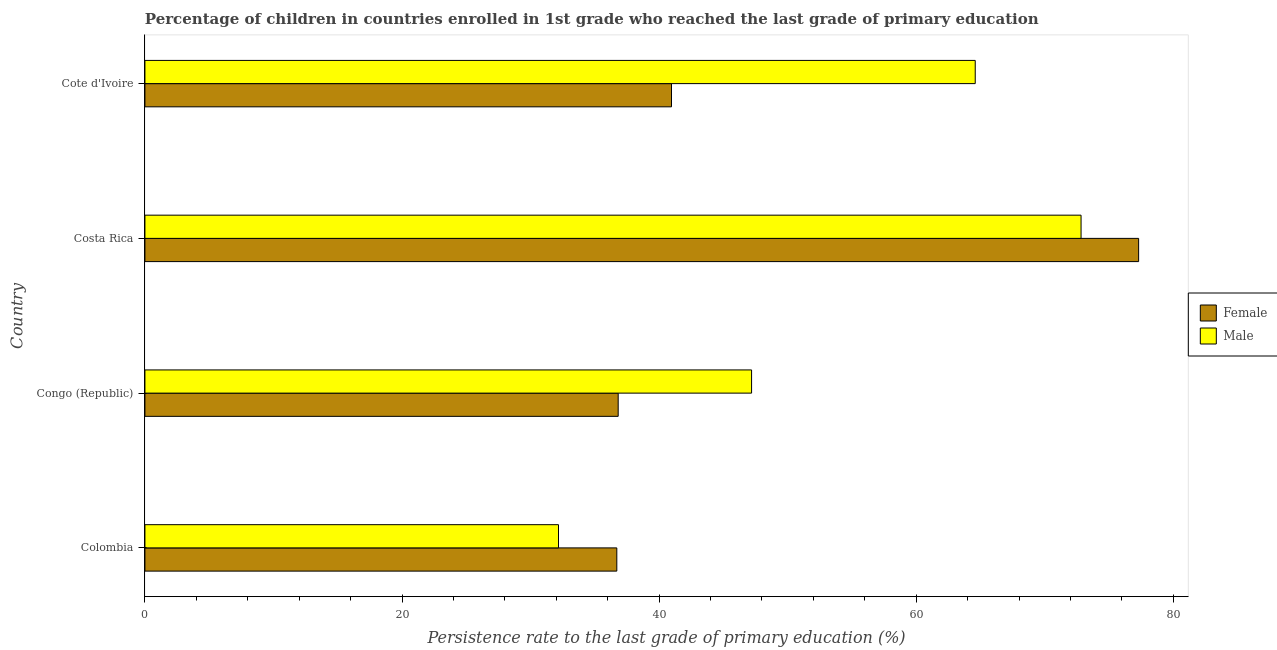How many different coloured bars are there?
Provide a succinct answer. 2. How many groups of bars are there?
Make the answer very short. 4. Are the number of bars on each tick of the Y-axis equal?
Give a very brief answer. Yes. How many bars are there on the 2nd tick from the bottom?
Provide a succinct answer. 2. What is the label of the 4th group of bars from the top?
Your answer should be very brief. Colombia. In how many cases, is the number of bars for a given country not equal to the number of legend labels?
Ensure brevity in your answer.  0. What is the persistence rate of male students in Colombia?
Ensure brevity in your answer.  32.17. Across all countries, what is the maximum persistence rate of female students?
Make the answer very short. 77.3. Across all countries, what is the minimum persistence rate of female students?
Provide a succinct answer. 36.71. In which country was the persistence rate of female students maximum?
Offer a terse response. Costa Rica. What is the total persistence rate of female students in the graph?
Offer a terse response. 191.79. What is the difference between the persistence rate of male students in Colombia and that in Cote d'Ivoire?
Provide a succinct answer. -32.42. What is the difference between the persistence rate of female students in Costa Rica and the persistence rate of male students in Colombia?
Give a very brief answer. 45.13. What is the average persistence rate of male students per country?
Your answer should be compact. 54.2. What is the difference between the persistence rate of female students and persistence rate of male students in Costa Rica?
Your response must be concise. 4.48. What is the ratio of the persistence rate of female students in Colombia to that in Costa Rica?
Your answer should be compact. 0.47. Is the difference between the persistence rate of female students in Colombia and Congo (Republic) greater than the difference between the persistence rate of male students in Colombia and Congo (Republic)?
Your answer should be compact. Yes. What is the difference between the highest and the second highest persistence rate of male students?
Offer a very short reply. 8.23. What is the difference between the highest and the lowest persistence rate of male students?
Your response must be concise. 40.65. What does the 2nd bar from the bottom in Costa Rica represents?
Provide a succinct answer. Male. How many bars are there?
Your answer should be very brief. 8. How many countries are there in the graph?
Make the answer very short. 4. What is the difference between two consecutive major ticks on the X-axis?
Make the answer very short. 20. Does the graph contain any zero values?
Provide a succinct answer. No. Does the graph contain grids?
Give a very brief answer. No. Where does the legend appear in the graph?
Provide a short and direct response. Center right. How many legend labels are there?
Ensure brevity in your answer.  2. What is the title of the graph?
Give a very brief answer. Percentage of children in countries enrolled in 1st grade who reached the last grade of primary education. Does "Infant" appear as one of the legend labels in the graph?
Provide a succinct answer. No. What is the label or title of the X-axis?
Your response must be concise. Persistence rate to the last grade of primary education (%). What is the label or title of the Y-axis?
Your response must be concise. Country. What is the Persistence rate to the last grade of primary education (%) in Female in Colombia?
Your response must be concise. 36.71. What is the Persistence rate to the last grade of primary education (%) in Male in Colombia?
Make the answer very short. 32.17. What is the Persistence rate to the last grade of primary education (%) of Female in Congo (Republic)?
Provide a succinct answer. 36.82. What is the Persistence rate to the last grade of primary education (%) in Male in Congo (Republic)?
Your answer should be very brief. 47.19. What is the Persistence rate to the last grade of primary education (%) of Female in Costa Rica?
Keep it short and to the point. 77.3. What is the Persistence rate to the last grade of primary education (%) of Male in Costa Rica?
Ensure brevity in your answer.  72.82. What is the Persistence rate to the last grade of primary education (%) in Female in Cote d'Ivoire?
Ensure brevity in your answer.  40.96. What is the Persistence rate to the last grade of primary education (%) of Male in Cote d'Ivoire?
Provide a short and direct response. 64.59. Across all countries, what is the maximum Persistence rate to the last grade of primary education (%) of Female?
Make the answer very short. 77.3. Across all countries, what is the maximum Persistence rate to the last grade of primary education (%) in Male?
Keep it short and to the point. 72.82. Across all countries, what is the minimum Persistence rate to the last grade of primary education (%) of Female?
Provide a succinct answer. 36.71. Across all countries, what is the minimum Persistence rate to the last grade of primary education (%) in Male?
Offer a terse response. 32.17. What is the total Persistence rate to the last grade of primary education (%) of Female in the graph?
Provide a short and direct response. 191.79. What is the total Persistence rate to the last grade of primary education (%) in Male in the graph?
Offer a terse response. 216.78. What is the difference between the Persistence rate to the last grade of primary education (%) in Female in Colombia and that in Congo (Republic)?
Make the answer very short. -0.11. What is the difference between the Persistence rate to the last grade of primary education (%) of Male in Colombia and that in Congo (Republic)?
Offer a very short reply. -15.02. What is the difference between the Persistence rate to the last grade of primary education (%) in Female in Colombia and that in Costa Rica?
Make the answer very short. -40.59. What is the difference between the Persistence rate to the last grade of primary education (%) in Male in Colombia and that in Costa Rica?
Offer a very short reply. -40.65. What is the difference between the Persistence rate to the last grade of primary education (%) in Female in Colombia and that in Cote d'Ivoire?
Your answer should be compact. -4.25. What is the difference between the Persistence rate to the last grade of primary education (%) of Male in Colombia and that in Cote d'Ivoire?
Offer a very short reply. -32.42. What is the difference between the Persistence rate to the last grade of primary education (%) of Female in Congo (Republic) and that in Costa Rica?
Provide a short and direct response. -40.49. What is the difference between the Persistence rate to the last grade of primary education (%) of Male in Congo (Republic) and that in Costa Rica?
Make the answer very short. -25.63. What is the difference between the Persistence rate to the last grade of primary education (%) in Female in Congo (Republic) and that in Cote d'Ivoire?
Your response must be concise. -4.15. What is the difference between the Persistence rate to the last grade of primary education (%) in Male in Congo (Republic) and that in Cote d'Ivoire?
Offer a terse response. -17.4. What is the difference between the Persistence rate to the last grade of primary education (%) of Female in Costa Rica and that in Cote d'Ivoire?
Ensure brevity in your answer.  36.34. What is the difference between the Persistence rate to the last grade of primary education (%) of Male in Costa Rica and that in Cote d'Ivoire?
Your answer should be very brief. 8.23. What is the difference between the Persistence rate to the last grade of primary education (%) in Female in Colombia and the Persistence rate to the last grade of primary education (%) in Male in Congo (Republic)?
Give a very brief answer. -10.48. What is the difference between the Persistence rate to the last grade of primary education (%) of Female in Colombia and the Persistence rate to the last grade of primary education (%) of Male in Costa Rica?
Offer a terse response. -36.11. What is the difference between the Persistence rate to the last grade of primary education (%) of Female in Colombia and the Persistence rate to the last grade of primary education (%) of Male in Cote d'Ivoire?
Ensure brevity in your answer.  -27.88. What is the difference between the Persistence rate to the last grade of primary education (%) in Female in Congo (Republic) and the Persistence rate to the last grade of primary education (%) in Male in Costa Rica?
Give a very brief answer. -36.01. What is the difference between the Persistence rate to the last grade of primary education (%) in Female in Congo (Republic) and the Persistence rate to the last grade of primary education (%) in Male in Cote d'Ivoire?
Provide a succinct answer. -27.77. What is the difference between the Persistence rate to the last grade of primary education (%) in Female in Costa Rica and the Persistence rate to the last grade of primary education (%) in Male in Cote d'Ivoire?
Provide a short and direct response. 12.71. What is the average Persistence rate to the last grade of primary education (%) in Female per country?
Provide a short and direct response. 47.95. What is the average Persistence rate to the last grade of primary education (%) of Male per country?
Your answer should be very brief. 54.19. What is the difference between the Persistence rate to the last grade of primary education (%) of Female and Persistence rate to the last grade of primary education (%) of Male in Colombia?
Keep it short and to the point. 4.54. What is the difference between the Persistence rate to the last grade of primary education (%) of Female and Persistence rate to the last grade of primary education (%) of Male in Congo (Republic)?
Provide a succinct answer. -10.38. What is the difference between the Persistence rate to the last grade of primary education (%) in Female and Persistence rate to the last grade of primary education (%) in Male in Costa Rica?
Your response must be concise. 4.48. What is the difference between the Persistence rate to the last grade of primary education (%) in Female and Persistence rate to the last grade of primary education (%) in Male in Cote d'Ivoire?
Provide a short and direct response. -23.63. What is the ratio of the Persistence rate to the last grade of primary education (%) in Male in Colombia to that in Congo (Republic)?
Your response must be concise. 0.68. What is the ratio of the Persistence rate to the last grade of primary education (%) of Female in Colombia to that in Costa Rica?
Make the answer very short. 0.47. What is the ratio of the Persistence rate to the last grade of primary education (%) in Male in Colombia to that in Costa Rica?
Provide a short and direct response. 0.44. What is the ratio of the Persistence rate to the last grade of primary education (%) of Female in Colombia to that in Cote d'Ivoire?
Keep it short and to the point. 0.9. What is the ratio of the Persistence rate to the last grade of primary education (%) of Male in Colombia to that in Cote d'Ivoire?
Provide a short and direct response. 0.5. What is the ratio of the Persistence rate to the last grade of primary education (%) in Female in Congo (Republic) to that in Costa Rica?
Keep it short and to the point. 0.48. What is the ratio of the Persistence rate to the last grade of primary education (%) in Male in Congo (Republic) to that in Costa Rica?
Offer a terse response. 0.65. What is the ratio of the Persistence rate to the last grade of primary education (%) in Female in Congo (Republic) to that in Cote d'Ivoire?
Give a very brief answer. 0.9. What is the ratio of the Persistence rate to the last grade of primary education (%) in Male in Congo (Republic) to that in Cote d'Ivoire?
Make the answer very short. 0.73. What is the ratio of the Persistence rate to the last grade of primary education (%) in Female in Costa Rica to that in Cote d'Ivoire?
Provide a short and direct response. 1.89. What is the ratio of the Persistence rate to the last grade of primary education (%) of Male in Costa Rica to that in Cote d'Ivoire?
Offer a terse response. 1.13. What is the difference between the highest and the second highest Persistence rate to the last grade of primary education (%) of Female?
Your answer should be very brief. 36.34. What is the difference between the highest and the second highest Persistence rate to the last grade of primary education (%) of Male?
Make the answer very short. 8.23. What is the difference between the highest and the lowest Persistence rate to the last grade of primary education (%) in Female?
Offer a very short reply. 40.59. What is the difference between the highest and the lowest Persistence rate to the last grade of primary education (%) in Male?
Your answer should be compact. 40.65. 